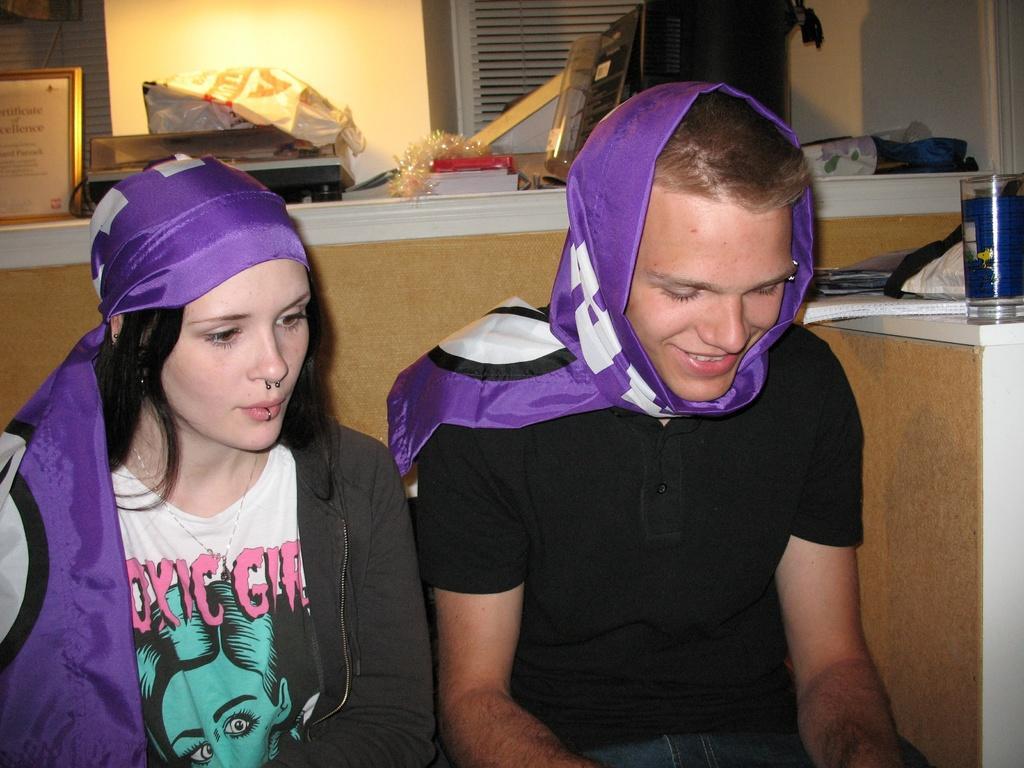Can you describe this image briefly? In this image we can see two persons and the persons are wearing scarves. Behind the persons we can see a wall and few objects on the table. On the right side, we can see few objects on a table. 